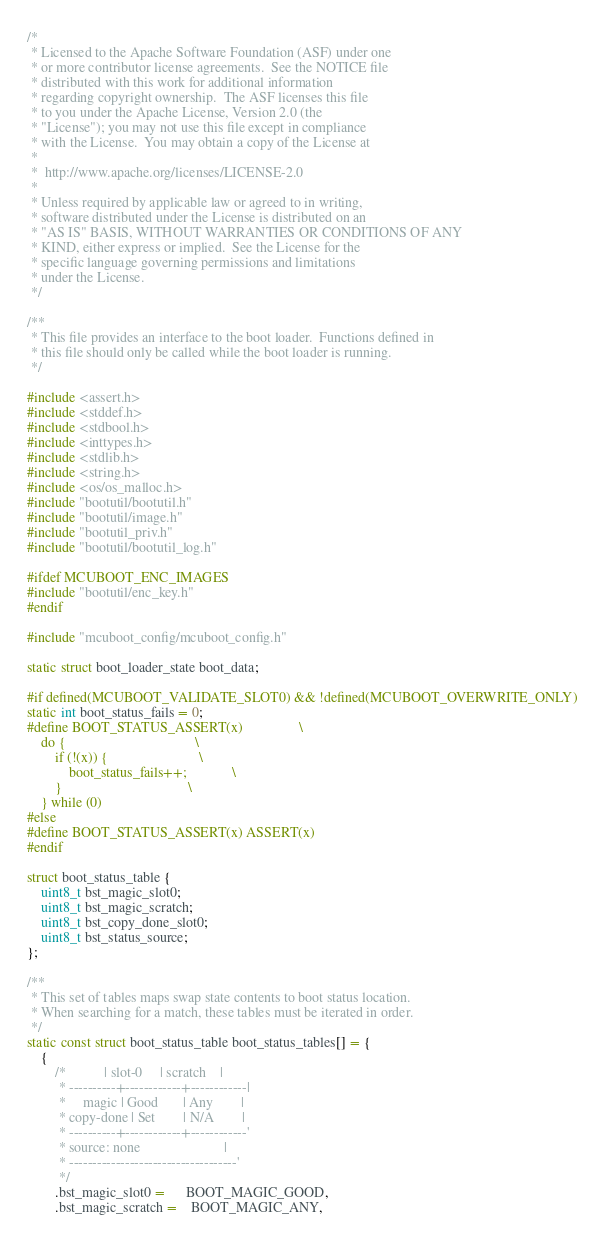Convert code to text. <code><loc_0><loc_0><loc_500><loc_500><_C_>/*
 * Licensed to the Apache Software Foundation (ASF) under one
 * or more contributor license agreements.  See the NOTICE file
 * distributed with this work for additional information
 * regarding copyright ownership.  The ASF licenses this file
 * to you under the Apache License, Version 2.0 (the
 * "License"); you may not use this file except in compliance
 * with the License.  You may obtain a copy of the License at
 *
 *  http://www.apache.org/licenses/LICENSE-2.0
 *
 * Unless required by applicable law or agreed to in writing,
 * software distributed under the License is distributed on an
 * "AS IS" BASIS, WITHOUT WARRANTIES OR CONDITIONS OF ANY
 * KIND, either express or implied.  See the License for the
 * specific language governing permissions and limitations
 * under the License.
 */

/**
 * This file provides an interface to the boot loader.  Functions defined in
 * this file should only be called while the boot loader is running.
 */

#include <assert.h>
#include <stddef.h>
#include <stdbool.h>
#include <inttypes.h>
#include <stdlib.h>
#include <string.h>
#include <os/os_malloc.h>
#include "bootutil/bootutil.h"
#include "bootutil/image.h"
#include "bootutil_priv.h"
#include "bootutil/bootutil_log.h"

#ifdef MCUBOOT_ENC_IMAGES
#include "bootutil/enc_key.h"
#endif

#include "mcuboot_config/mcuboot_config.h"

static struct boot_loader_state boot_data;

#if defined(MCUBOOT_VALIDATE_SLOT0) && !defined(MCUBOOT_OVERWRITE_ONLY)
static int boot_status_fails = 0;
#define BOOT_STATUS_ASSERT(x)                \
    do {                                     \
        if (!(x)) {                          \
            boot_status_fails++;             \
        }                                    \
    } while (0)
#else
#define BOOT_STATUS_ASSERT(x) ASSERT(x)
#endif

struct boot_status_table {
    uint8_t bst_magic_slot0;
    uint8_t bst_magic_scratch;
    uint8_t bst_copy_done_slot0;
    uint8_t bst_status_source;
};

/**
 * This set of tables maps swap state contents to boot status location.
 * When searching for a match, these tables must be iterated in order.
 */
static const struct boot_status_table boot_status_tables[] = {
    {
        /*           | slot-0     | scratch    |
         * ----------+------------+------------|
         *     magic | Good       | Any        |
         * copy-done | Set        | N/A        |
         * ----------+------------+------------'
         * source: none                        |
         * ------------------------------------'
         */
        .bst_magic_slot0 =      BOOT_MAGIC_GOOD,
        .bst_magic_scratch =    BOOT_MAGIC_ANY,</code> 